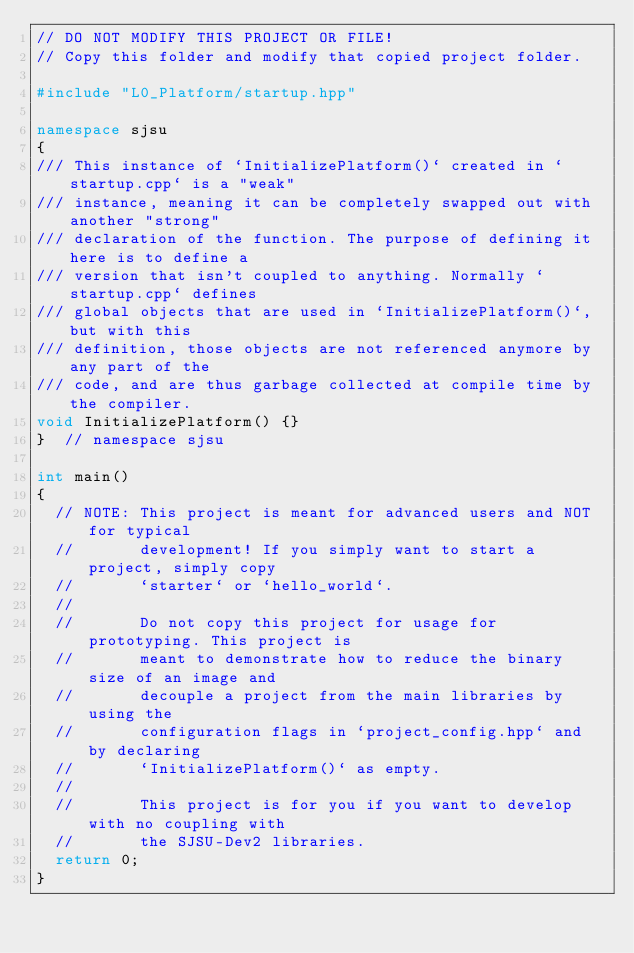Convert code to text. <code><loc_0><loc_0><loc_500><loc_500><_C++_>// DO NOT MODIFY THIS PROJECT OR FILE!
// Copy this folder and modify that copied project folder.

#include "L0_Platform/startup.hpp"

namespace sjsu
{
/// This instance of `InitializePlatform()` created in `startup.cpp` is a "weak"
/// instance, meaning it can be completely swapped out with another "strong"
/// declaration of the function. The purpose of defining it here is to define a
/// version that isn't coupled to anything. Normally `startup.cpp` defines
/// global objects that are used in `InitializePlatform()`, but with this
/// definition, those objects are not referenced anymore by any part of the
/// code, and are thus garbage collected at compile time by the compiler.
void InitializePlatform() {}
}  // namespace sjsu

int main()
{
  // NOTE: This project is meant for advanced users and NOT for typical
  //       development! If you simply want to start a project, simply copy
  //       `starter` or `hello_world`.
  //
  //       Do not copy this project for usage for prototyping. This project is
  //       meant to demonstrate how to reduce the binary size of an image and
  //       decouple a project from the main libraries by using the
  //       configuration flags in `project_config.hpp` and by declaring
  //       `InitializePlatform()` as empty.
  //
  //       This project is for you if you want to develop with no coupling with
  //       the SJSU-Dev2 libraries.
  return 0;
}
</code> 